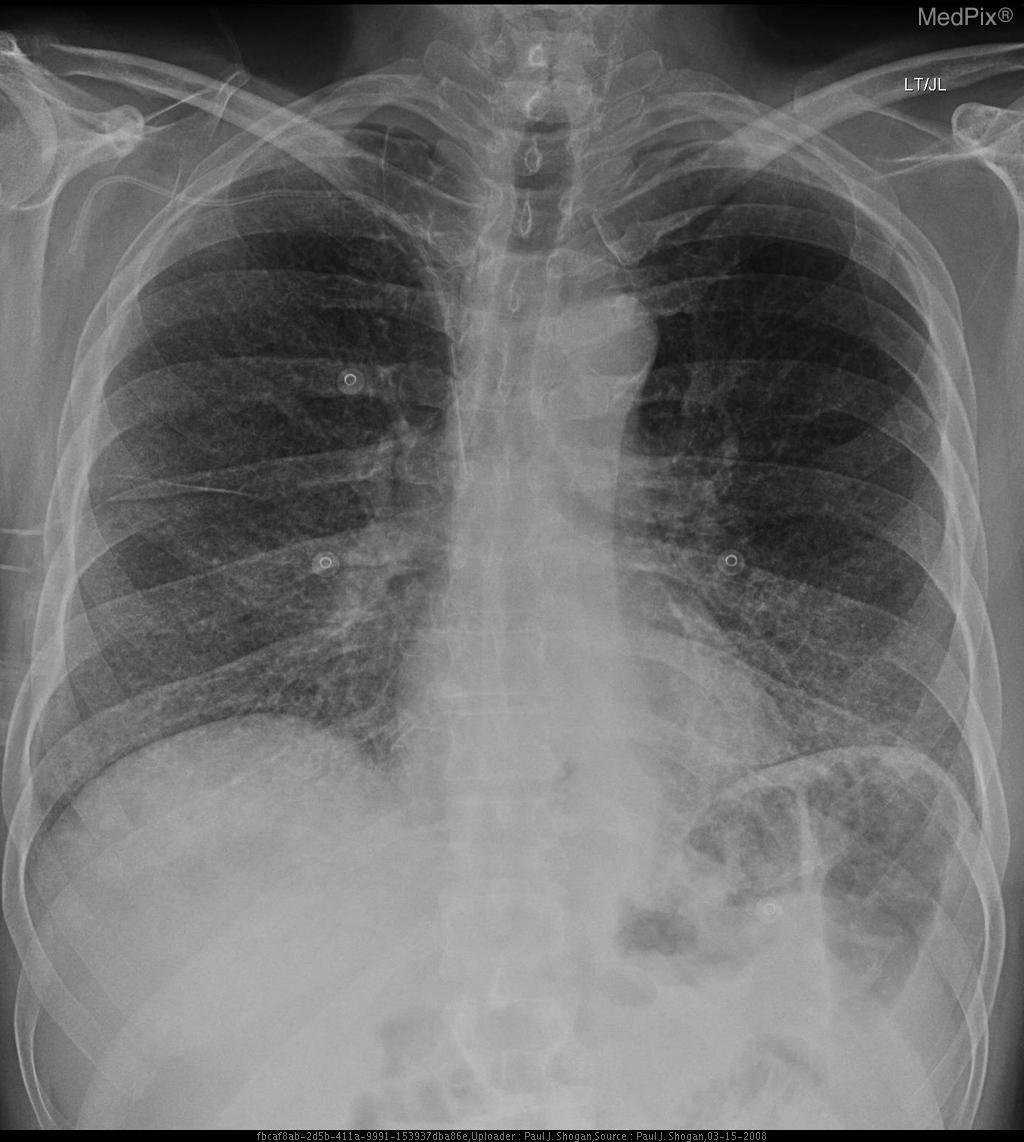Is the trachea midline?
Short answer required. Yes. Can you view the colon in this image?
Answer briefly. Yes. What structure is seen in the left hemidiaphragmatic area?
Quick response, please. Sigmoid flexture of the colon. What structure is superimposed on the left hemidiaphragm?
Answer briefly. Sigmoid flexture of the colon. What vein is the central venous catheter located in the patient?
Concise answer only. Right subclavian vein. Where is the central venous catheter placed?
Keep it brief. Right subclavian vein. Is this a chest radiograph?
Be succinct. Yes. Is this an ap or pa film?
Concise answer only. Pa. Are the ground glass opacities located more in the apex or base of the lung?
Quick response, please. Base. What parts of the lung fields contain the most prominent ground glass opacities?
Write a very short answer. Lower lung fields. 